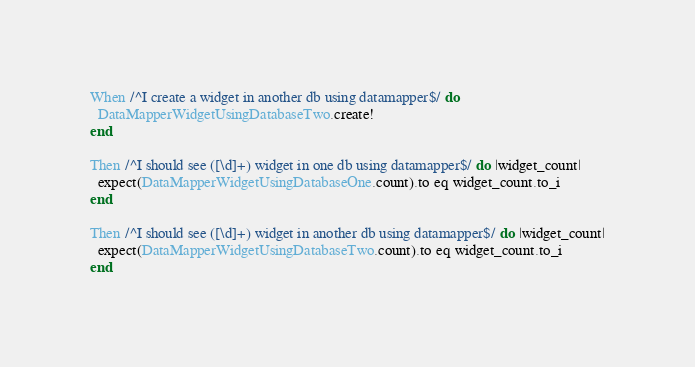<code> <loc_0><loc_0><loc_500><loc_500><_Ruby_>When /^I create a widget in another db using datamapper$/ do
  DataMapperWidgetUsingDatabaseTwo.create!
end

Then /^I should see ([\d]+) widget in one db using datamapper$/ do |widget_count|
  expect(DataMapperWidgetUsingDatabaseOne.count).to eq widget_count.to_i
end

Then /^I should see ([\d]+) widget in another db using datamapper$/ do |widget_count|
  expect(DataMapperWidgetUsingDatabaseTwo.count).to eq widget_count.to_i
end
</code> 